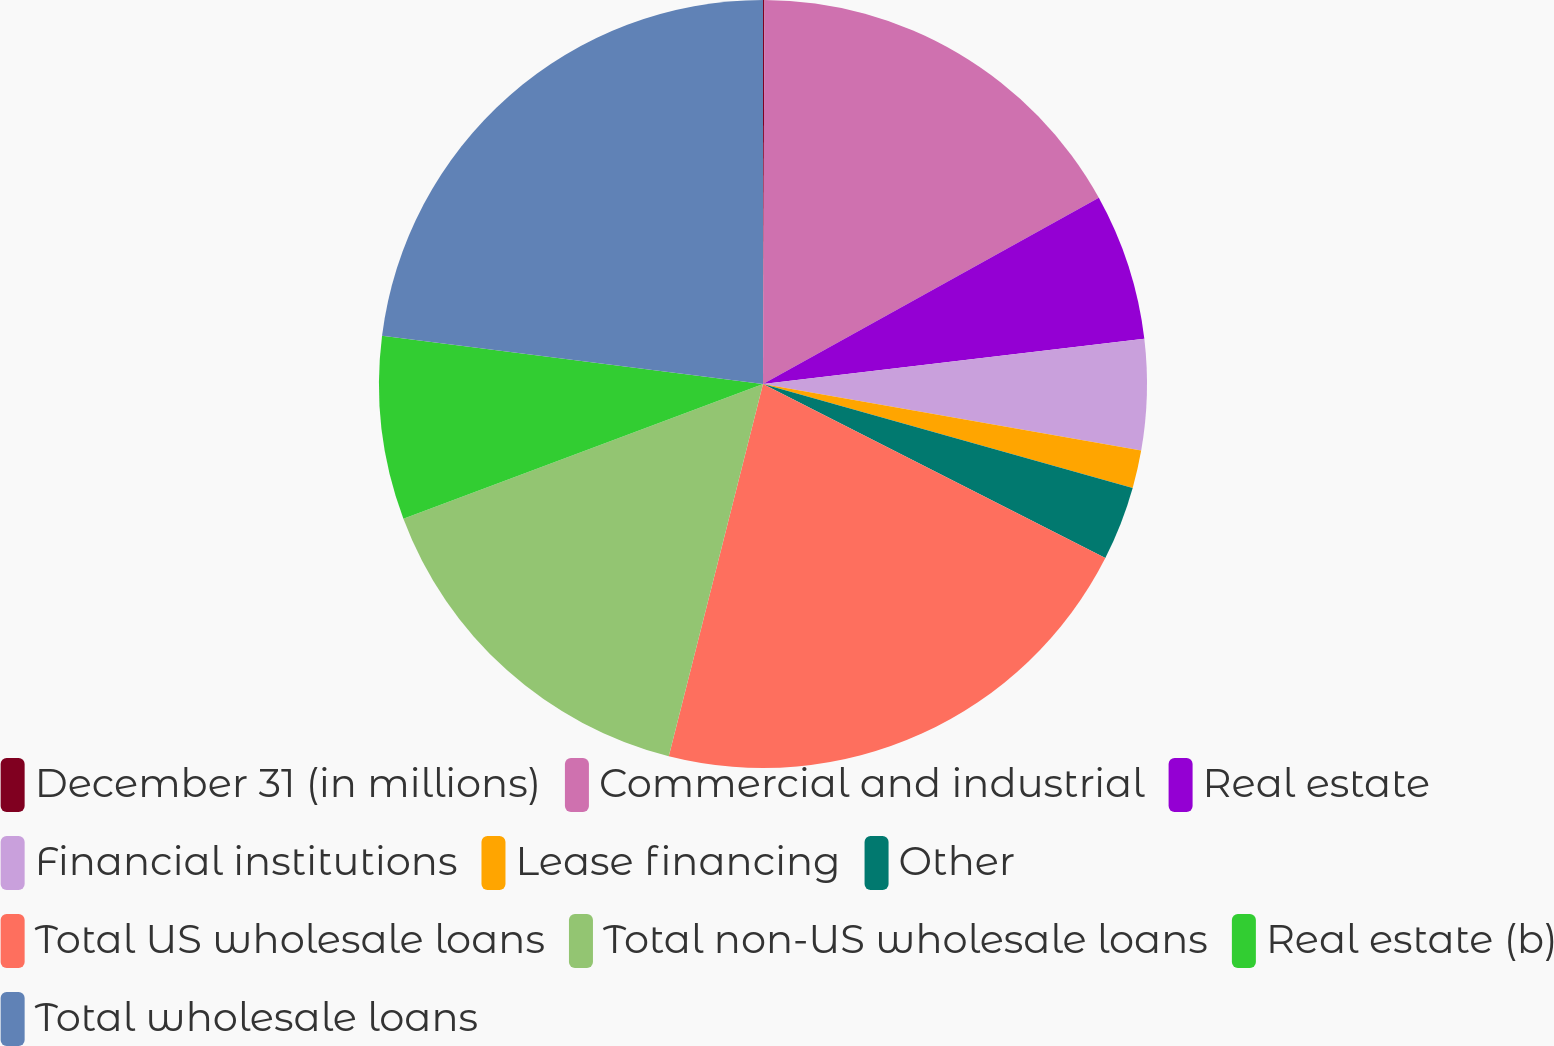Convert chart to OTSL. <chart><loc_0><loc_0><loc_500><loc_500><pie_chart><fcel>December 31 (in millions)<fcel>Commercial and industrial<fcel>Real estate<fcel>Financial institutions<fcel>Lease financing<fcel>Other<fcel>Total US wholesale loans<fcel>Total non-US wholesale loans<fcel>Real estate (b)<fcel>Total wholesale loans<nl><fcel>0.06%<fcel>16.88%<fcel>6.18%<fcel>4.65%<fcel>1.59%<fcel>3.12%<fcel>21.46%<fcel>15.35%<fcel>7.71%<fcel>22.99%<nl></chart> 